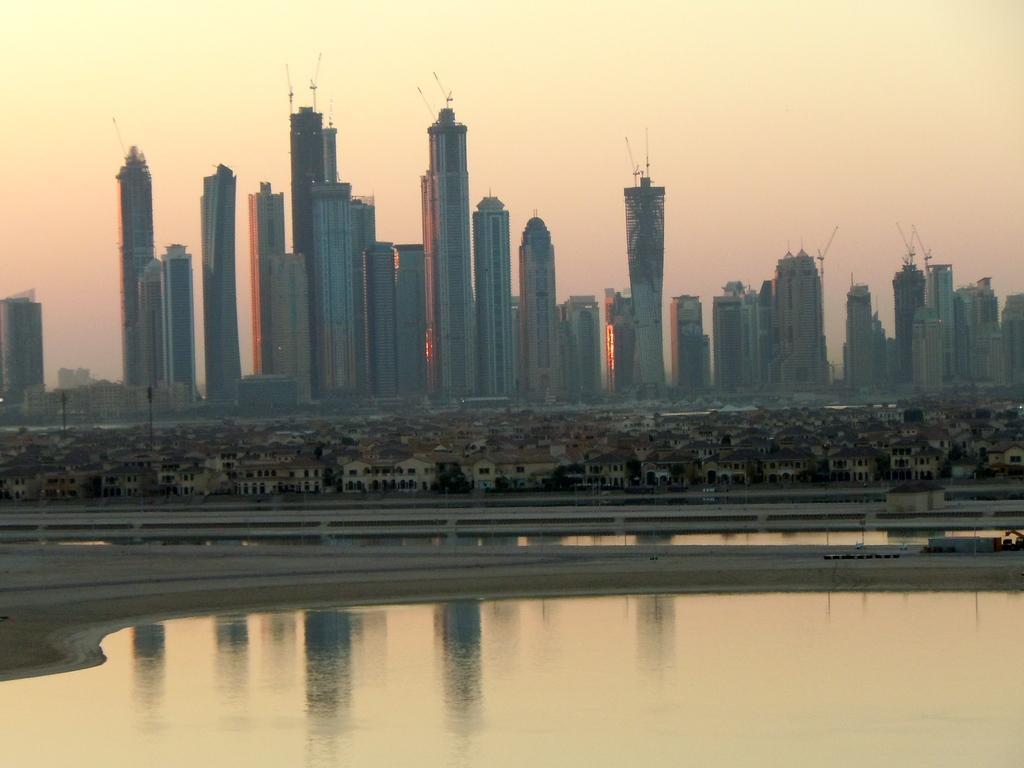Could you give a brief overview of what you see in this image? In this image we can see water, ground, a few buildings and sky in the background. 